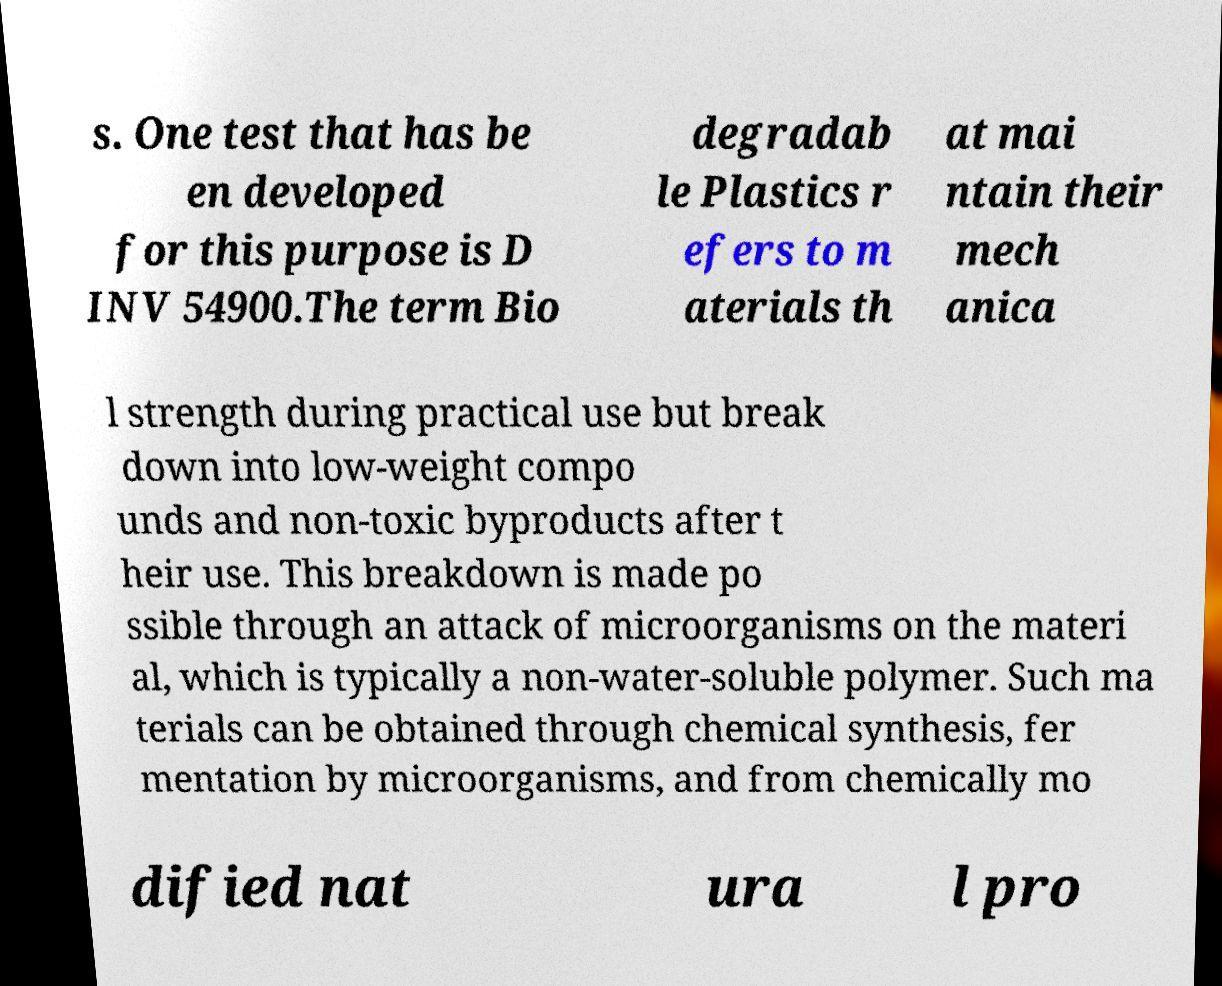Please identify and transcribe the text found in this image. s. One test that has be en developed for this purpose is D INV 54900.The term Bio degradab le Plastics r efers to m aterials th at mai ntain their mech anica l strength during practical use but break down into low-weight compo unds and non-toxic byproducts after t heir use. This breakdown is made po ssible through an attack of microorganisms on the materi al, which is typically a non-water-soluble polymer. Such ma terials can be obtained through chemical synthesis, fer mentation by microorganisms, and from chemically mo dified nat ura l pro 